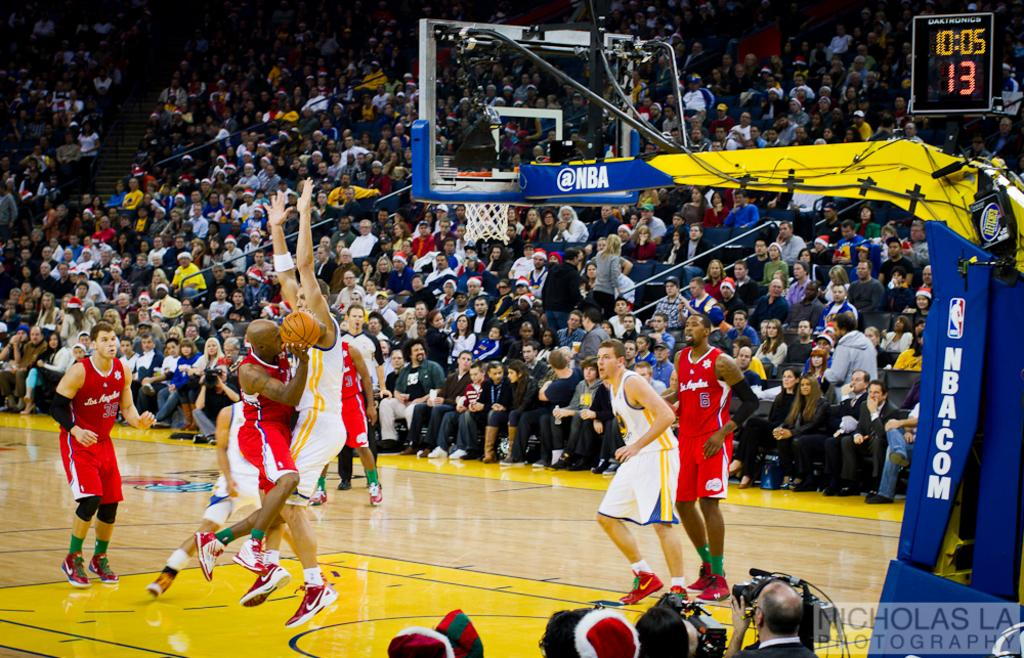<image>
Give a short and clear explanation of the subsequent image. a basketball game with NBA on the side of the basket 